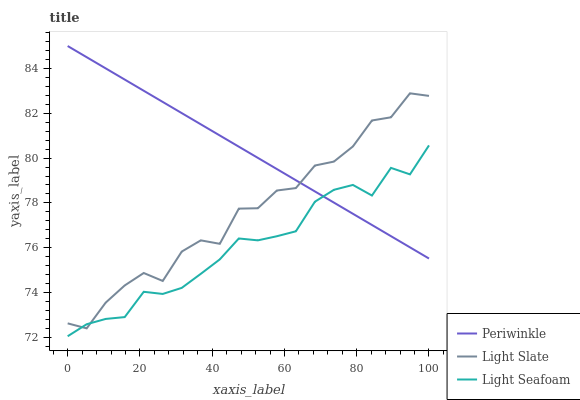Does Light Seafoam have the minimum area under the curve?
Answer yes or no. Yes. Does Periwinkle have the maximum area under the curve?
Answer yes or no. Yes. Does Periwinkle have the minimum area under the curve?
Answer yes or no. No. Does Light Seafoam have the maximum area under the curve?
Answer yes or no. No. Is Periwinkle the smoothest?
Answer yes or no. Yes. Is Light Slate the roughest?
Answer yes or no. Yes. Is Light Seafoam the smoothest?
Answer yes or no. No. Is Light Seafoam the roughest?
Answer yes or no. No. Does Light Seafoam have the lowest value?
Answer yes or no. Yes. Does Periwinkle have the lowest value?
Answer yes or no. No. Does Periwinkle have the highest value?
Answer yes or no. Yes. Does Light Seafoam have the highest value?
Answer yes or no. No. Does Light Seafoam intersect Periwinkle?
Answer yes or no. Yes. Is Light Seafoam less than Periwinkle?
Answer yes or no. No. Is Light Seafoam greater than Periwinkle?
Answer yes or no. No. 